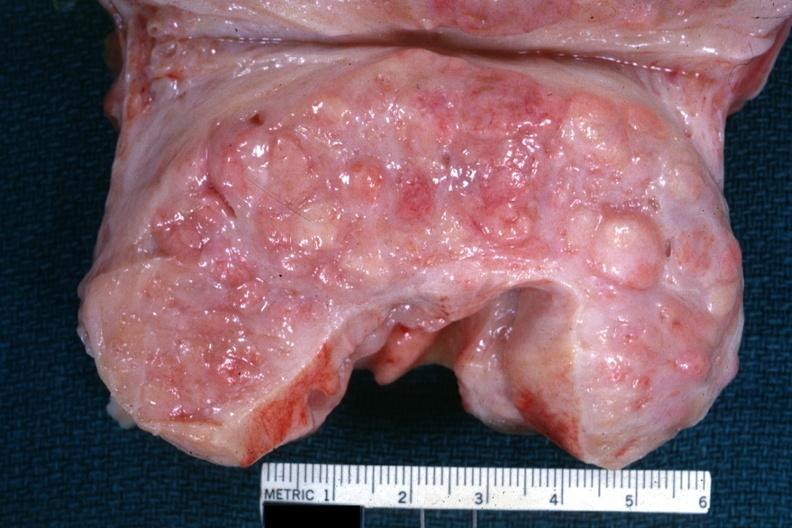s prostate present?
Answer the question using a single word or phrase. Yes 